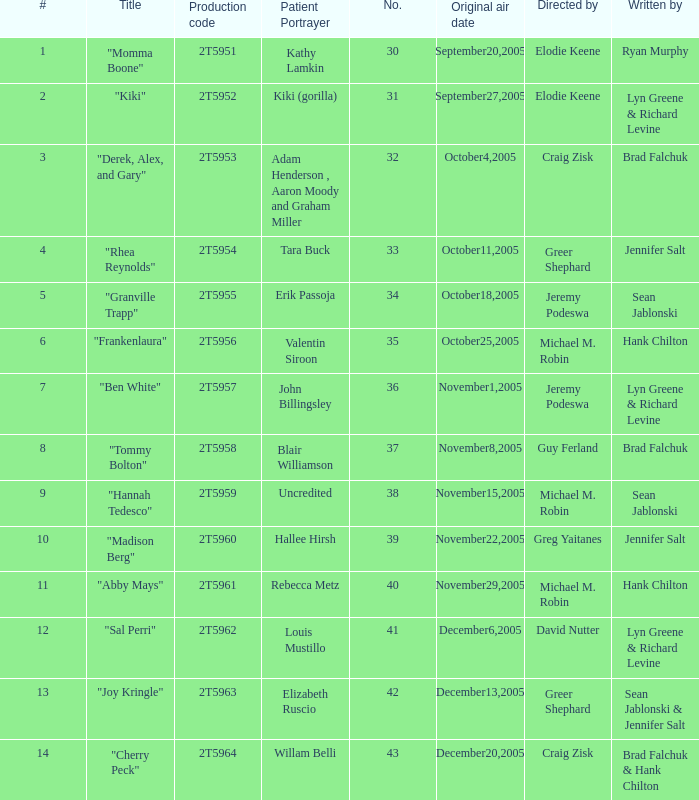What is the production code for the episode where the patient portrayer is Kathy Lamkin? 2T5951. 